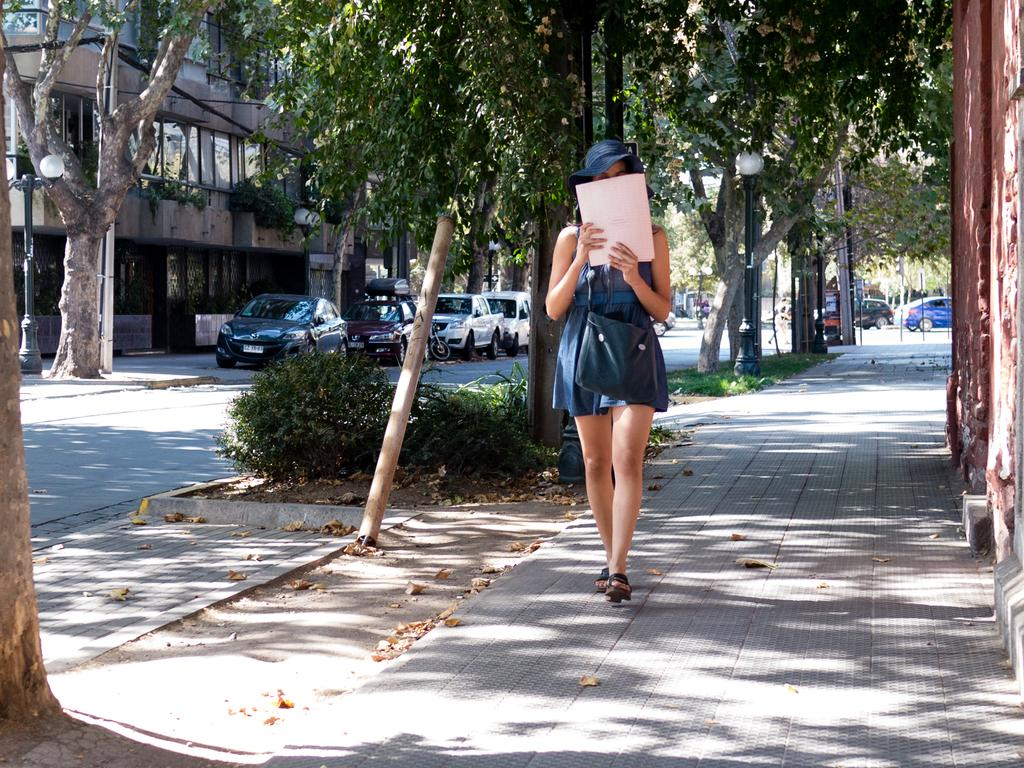What is the woman in the image doing? The woman is walking on the platform. What type of vegetation can be seen in the image? There are plants, grass, and trees in the image. What can be seen in the background of the image? There is a building in the background of the image. What type of infrastructure is present in the image? There are vehicles, a road, and poles in the image. What type of meat is being served on the paper in the image? There is no meat or paper present in the image. 